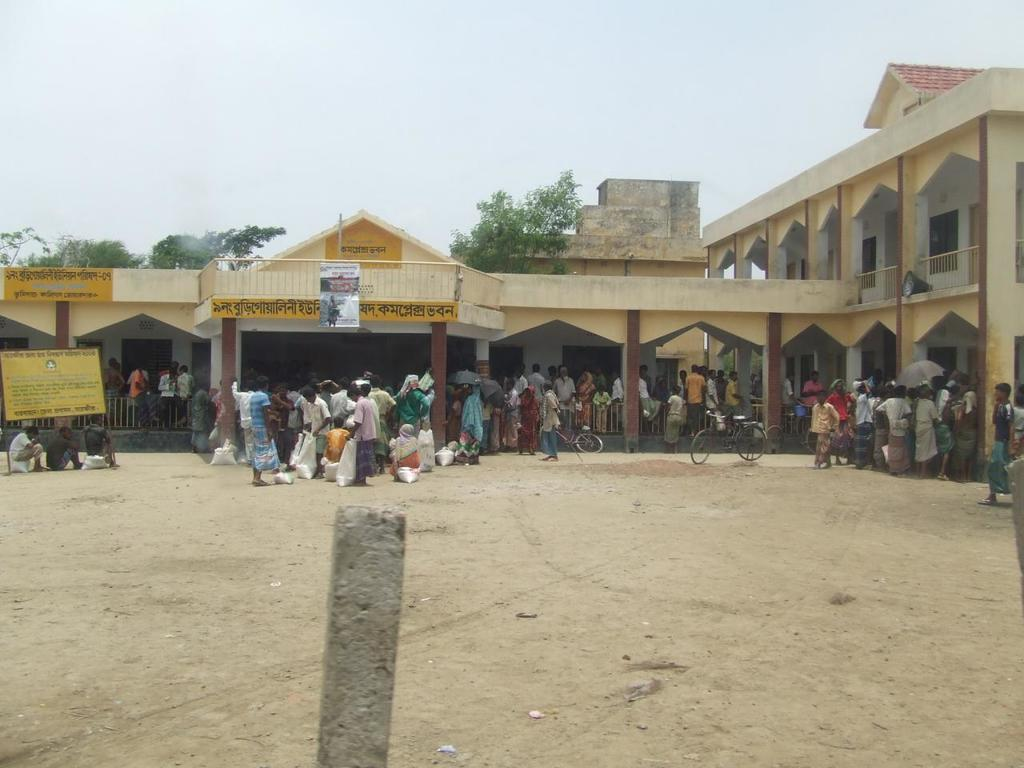What is located in the center of the image? There are persons and cycles in the center of the image, along with a building on the ground. What type of structure is present in the center of the image? There is a building on the ground in the center of the image. What can be seen at the bottom of the image? There is a pillar at the bottom of the image. What is visible in the background of the image? Trees and the sky are visible in the background of the image. How many chairs are visible in the image? There are no chairs present in the image. What type of wing is attached to the persons in the image? There are no wings present in the image; the persons are standing on the ground. 